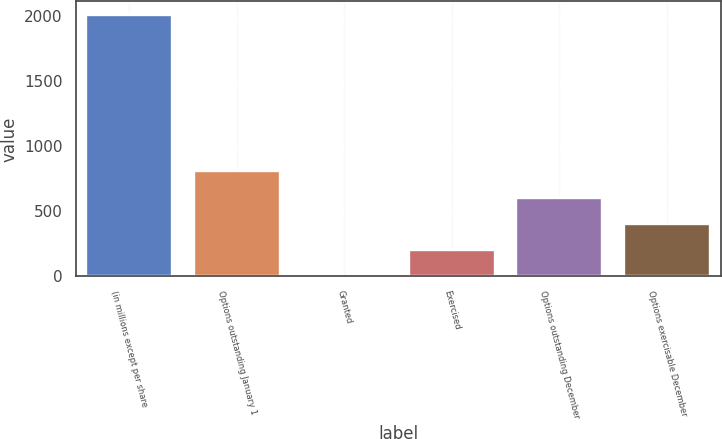<chart> <loc_0><loc_0><loc_500><loc_500><bar_chart><fcel>(in millions except per share<fcel>Options outstanding January 1<fcel>Granted<fcel>Exercised<fcel>Options outstanding December<fcel>Options exercisable December<nl><fcel>2013<fcel>805.74<fcel>0.9<fcel>202.11<fcel>604.53<fcel>403.32<nl></chart> 